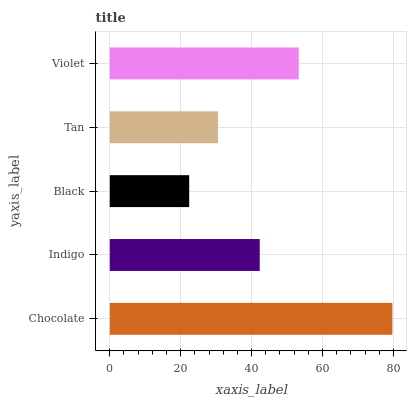Is Black the minimum?
Answer yes or no. Yes. Is Chocolate the maximum?
Answer yes or no. Yes. Is Indigo the minimum?
Answer yes or no. No. Is Indigo the maximum?
Answer yes or no. No. Is Chocolate greater than Indigo?
Answer yes or no. Yes. Is Indigo less than Chocolate?
Answer yes or no. Yes. Is Indigo greater than Chocolate?
Answer yes or no. No. Is Chocolate less than Indigo?
Answer yes or no. No. Is Indigo the high median?
Answer yes or no. Yes. Is Indigo the low median?
Answer yes or no. Yes. Is Chocolate the high median?
Answer yes or no. No. Is Tan the low median?
Answer yes or no. No. 